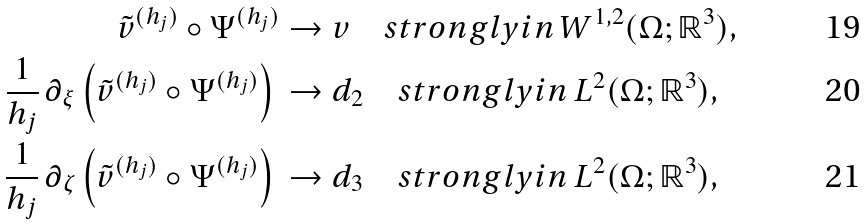Convert formula to latex. <formula><loc_0><loc_0><loc_500><loc_500>\tilde { v } ^ { ( h _ { j } ) } \circ \Psi ^ { ( h _ { j } ) } & \rightarrow v \quad s t r o n g l y i n \, W ^ { 1 , 2 } ( \Omega ; \mathbb { R } ^ { 3 } ) , \\ \frac { 1 } { h _ { j } } \, \partial _ { \xi } \left ( \tilde { v } ^ { ( h _ { j } ) } \circ \Psi ^ { ( h _ { j } ) } \right ) \, & \rightarrow d _ { 2 } \quad s t r o n g l y i n \, L ^ { 2 } ( \Omega ; \mathbb { R } ^ { 3 } ) , \\ \frac { 1 } { h _ { j } } \, \partial _ { \zeta } \left ( \tilde { v } ^ { ( h _ { j } ) } \circ \Psi ^ { ( h _ { j } ) } \right ) \, & \rightarrow d _ { 3 } \quad s t r o n g l y i n \, L ^ { 2 } ( \Omega ; \mathbb { R } ^ { 3 } ) ,</formula> 